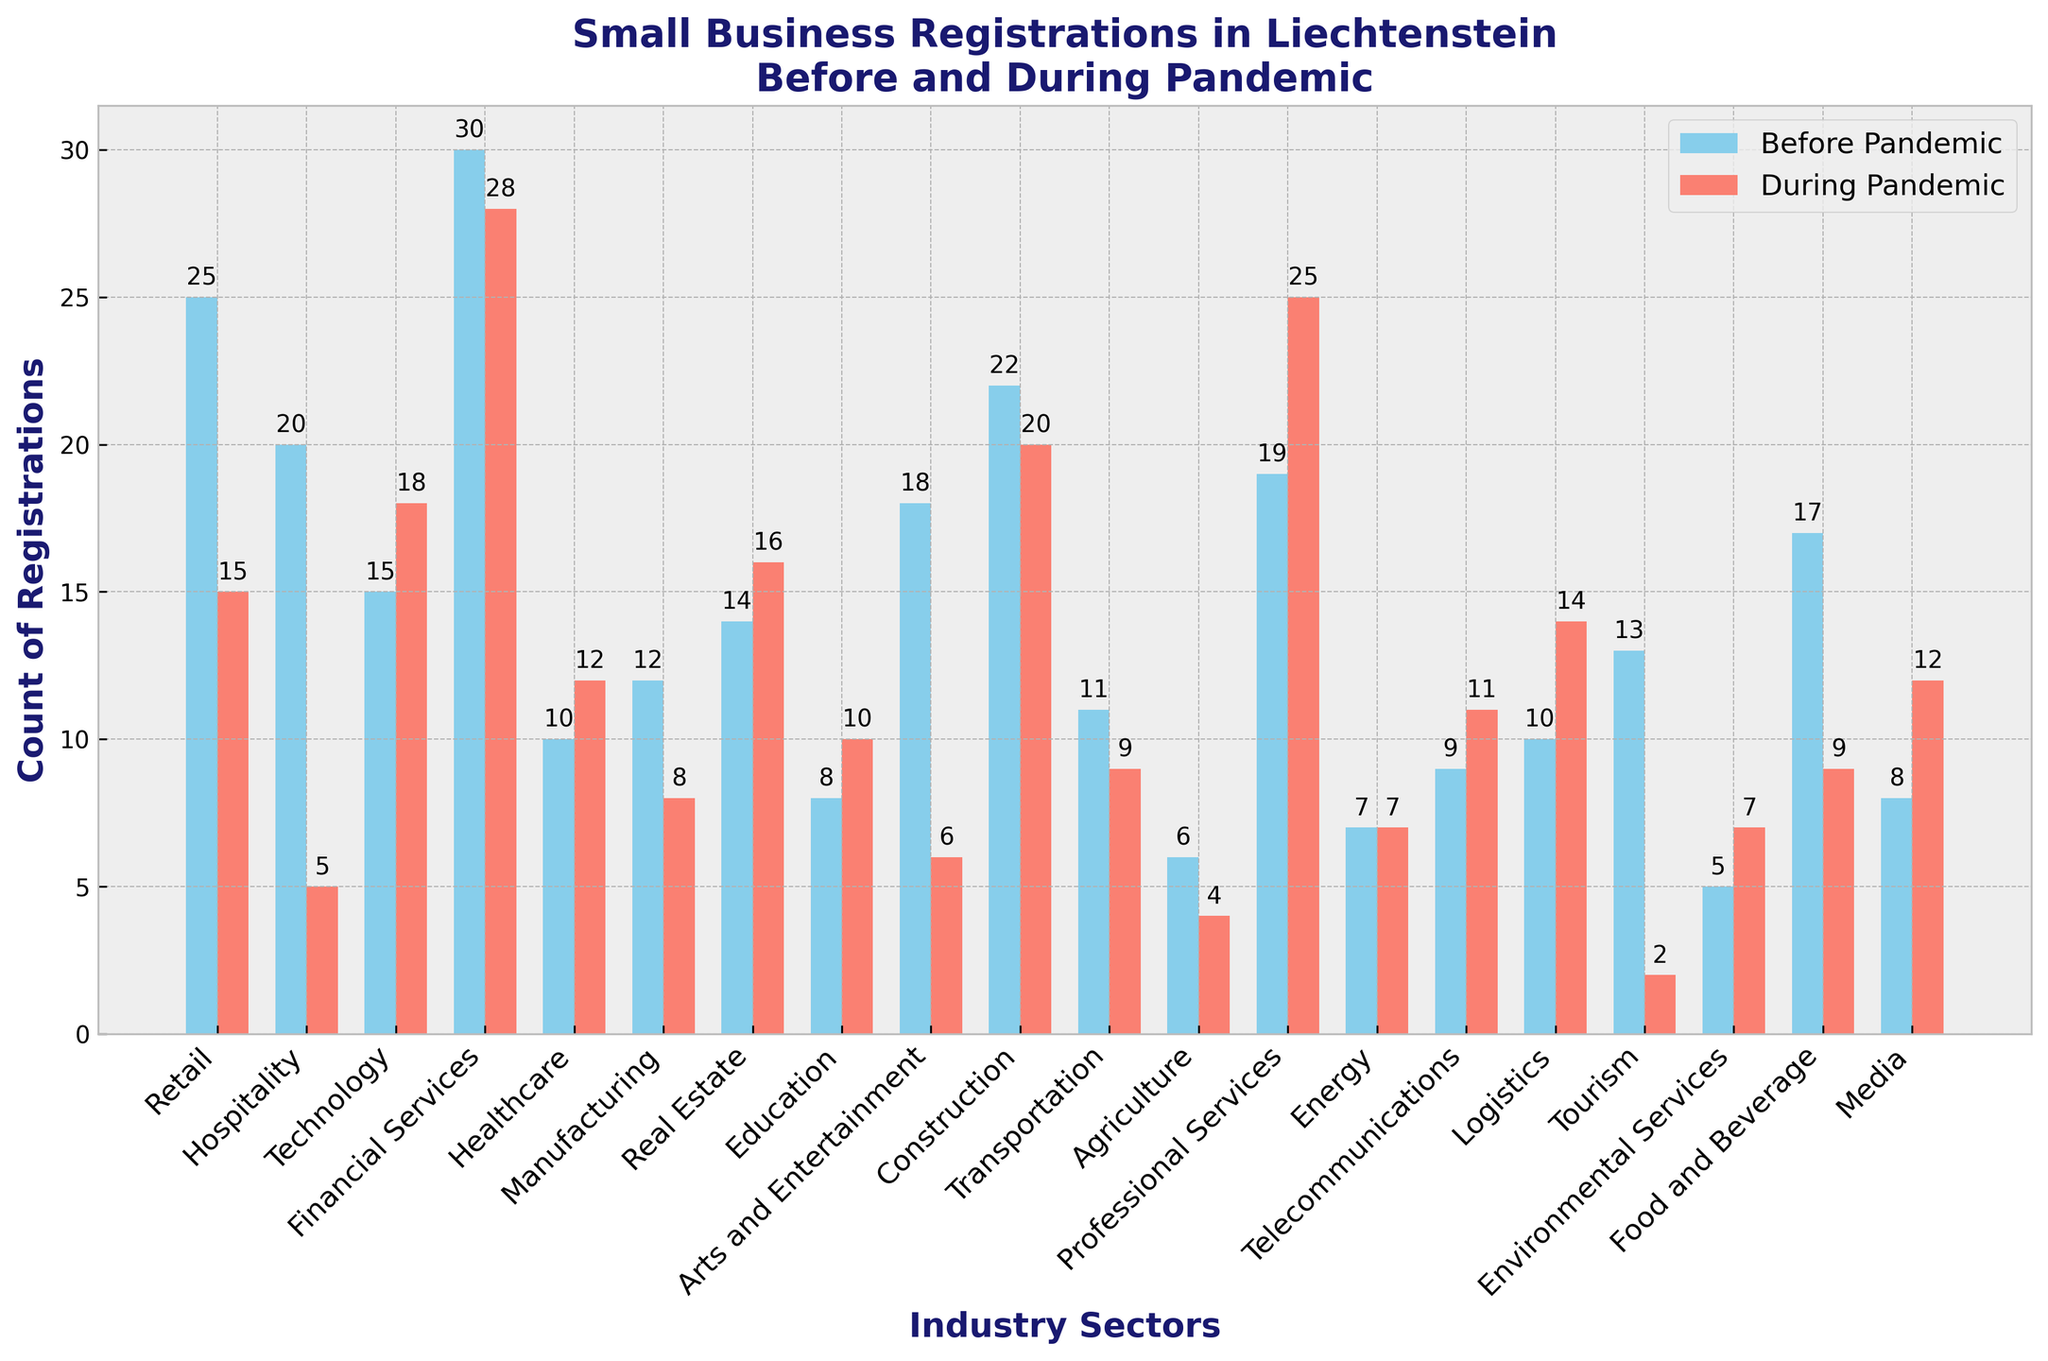Which industry saw the biggest drop in business registrations during the pandemic? The biggest drop can be identified by comparing the difference between 'Before Pandemic' and 'During Pandemic' counts for each industry. The drop is largest in Hospitality, where it went from 20 to 5 (a decrease of 15).
Answer: Hospitality Which industry experienced an increase in registrations during the pandemic? To see which industries had an increase, compare 'Before Pandemic' and 'During Pandemic' counts for all industries. Technology (15 to 18), Real Estate (14 to 16), Education (8 to 10), Professional Services (19 to 25), Environmental Services (5 to 7), Media (8 to 12), and Telecommunications (9 to 11) experienced increases.
Answer: Technology, Real Estate, Education, Professional Services, Environmental Services, Media, Telecommunications What is the combined total of registrations for the Financial Services sector before and during the pandemic? Add the number of registrations before and during the pandemic for Financial Services: 30 + 28 = 58.
Answer: 58 Compare the healthcare sector registrations to the technology sector during the pandemic. Which one had more? Check the 'During Pandemic' values for both Healthcare (12) and Technology (18). Technology had more registrations.
Answer: Technology What is the average number of registrations during the pandemic for the sectors that increased their registrations? The sectors that increased are Technology, Real Estate, Education, Professional Services, Environmental Services, Media, and Telecommunications. Their combined registrations are 18 + 16 + 10 + 25 + 7 + 12 + 11 = 99. There are 7 sectors, so the average is 99 / 7 ≈ 14.14.
Answer: 14.14 Which sector had the fewest registrations during the pandemic? Identify the lowest 'During Pandemic' count among all sectors. Agriculture had the fewest with 4 registrations.
Answer: Agriculture By how much did the number of registrations in the Arts and Entertainment sector change during the pandemic? Calculate the difference for Arts and Entertainment: 18 (Before) - 6 (During) = 12.
Answer: 12 Which sector had more registrations before the pandemic, Construction or Tourism? Compare the 'Before Pandemic' values for Construction (22) and Tourism (13). Construction had more registrations.
Answer: Construction What's the combined total of registrations before the pandemic for sectors with more than 15 registrations during the pandemic? Identify these sectors based on 'During Pandemic' counts: Technology (18), Financial Services (28), Real Estate (16), Professional Services (25). Their 'Before Pandemic' counts are 15, 30, 14, 19 respectively. The total is 15 + 30 + 14 + 19 = 78.
Answer: 78 What’s the difference in pandemic registrations between Retail and Food and Beverage? Compare 'During Pandemic' values for Retail (15) and Food and Beverage (9): 15 - 9 = 6.
Answer: 6 